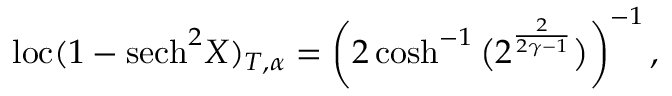<formula> <loc_0><loc_0><loc_500><loc_500>l o c ( 1 - s e c h ^ { 2 } X ) _ { T , \alpha } = \left ( 2 \cosh ^ { - 1 } \left ( 2 ^ { \frac { 2 } { 2 \gamma - 1 } } \right ) \right ) ^ { - 1 } ,</formula> 